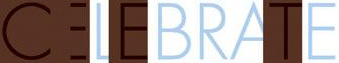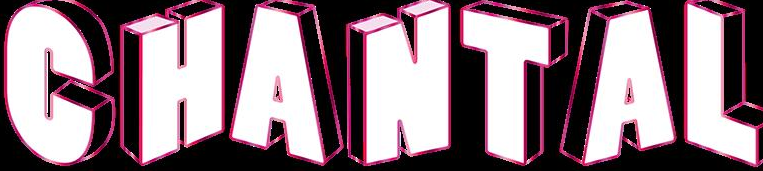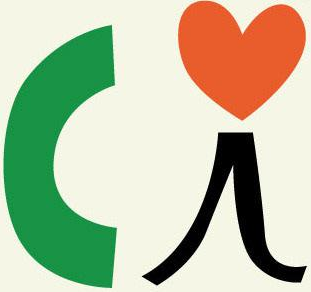Transcribe the words shown in these images in order, separated by a semicolon. CELEBRATE; CHANTAL; Ci 